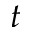<formula> <loc_0><loc_0><loc_500><loc_500>t</formula> 